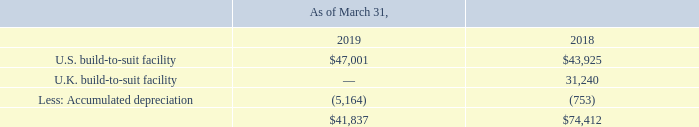(1) Includes construction costs capitalized related to build-to-suit facilities:
As of March 31, 2019 and 2018, the U.S. build-to-suit facility includes company-funded building improvements of $5.2 million and $4.5 million, respectively. In March 2019, the Company derecognized the U.K. build-to-suit facility upon substantial completion of construction. See Note 12 for further details.
How much was the company-funded building improvements as of March 31, 2019? $5.2 million. How much was the company-funded building improvements as of March 31, 2018? $4.5 million. When did the Company derecognized the U.K. build-to-suit facility upon substantial completion of construction? March 2019. What is the change in U.S. build-to-suit facility from March 31, 2018 to March 31, 2019? 47,001-43,925
Answer: 3076. What is the change in Accumulated depreciation from March 31, 2018 to March 31, 2019? 5,164-753
Answer: 4411. What is the average U.S. build-to-suit facility for March 31, 2018 to March 31, 2019? (47,001+43,925) / 2
Answer: 45463. 